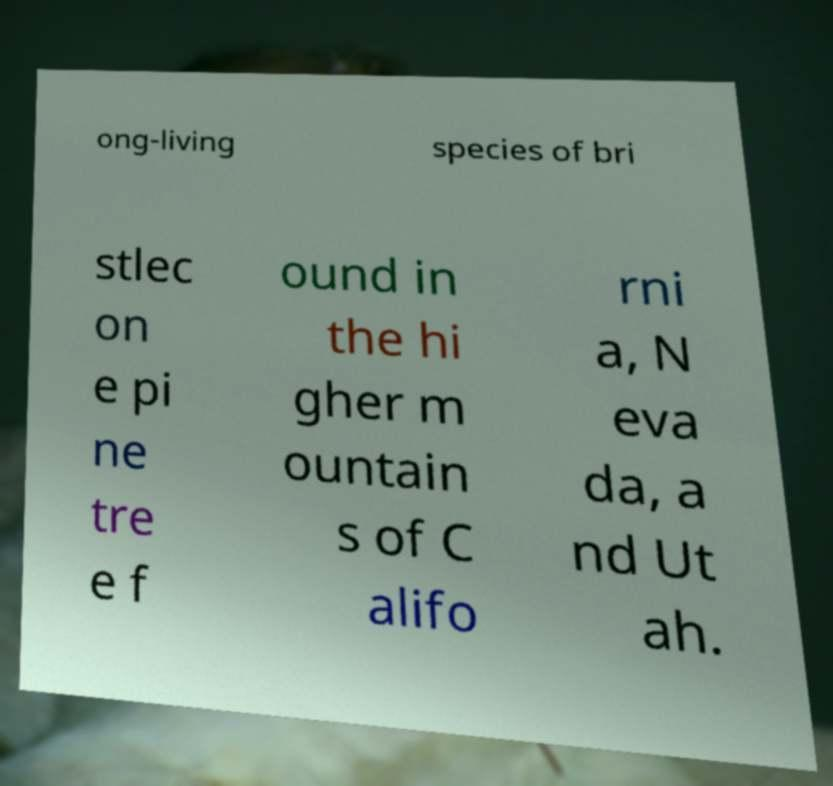Please identify and transcribe the text found in this image. ong-living species of bri stlec on e pi ne tre e f ound in the hi gher m ountain s of C alifo rni a, N eva da, a nd Ut ah. 